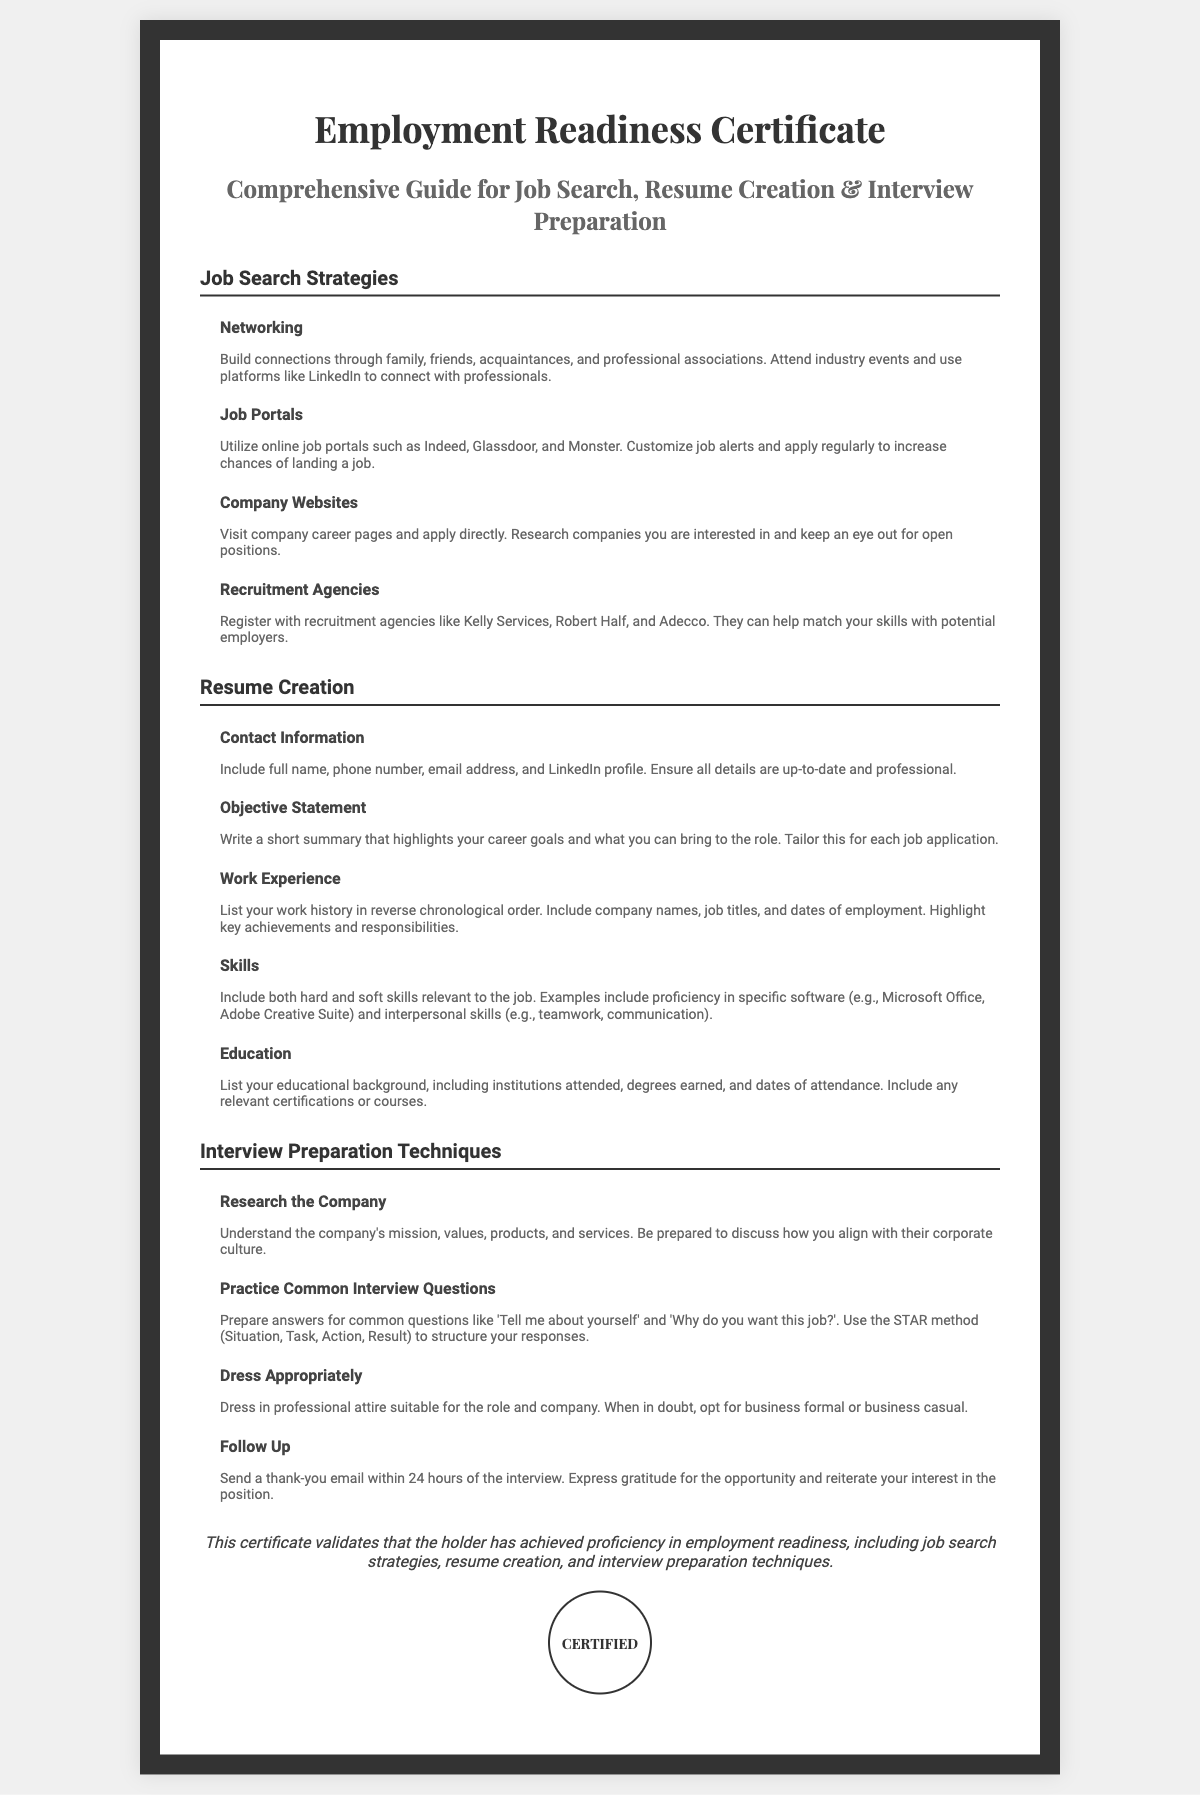What is the title of the document? The title of the document is indicated prominently at the top, which describes its purpose.
Answer: Employment Readiness Certificate How many sections are in the document? The document contains distinct sections that are outlined under headings. Counting these gives a total of three main sections.
Answer: 3 What is one job search strategy mentioned? The document lists several strategies for job searching, one of which is explicitly named.
Answer: Networking What should be included in the contact information of a resume? The document specifies elements that are necessary in the contact information for a resume.
Answer: Full name, phone number, email address, and LinkedIn profile Which method should be used to prepare answers for common interview questions? The document refers to a specific method for structuring responses during interview preparation.
Answer: STAR method What should you do after an interview according to the document? The document advises a specific action to take following an interview to demonstrate professionalism.
Answer: Send a thank-you email Name one recruitment agency mentioned in the document. The document lists examples of recruitment agencies that can assist with job placement.
Answer: Kelly Services What is the purpose of the Employment Readiness Certificate? The document defines the objective of holding this certificate, stating the areas of proficiency covered.
Answer: Validate proficiency in employment readiness What type of dress is suggested for interviews? The document provides guidance on appropriate attire for interviews based on the company's environment.
Answer: Professional attire 